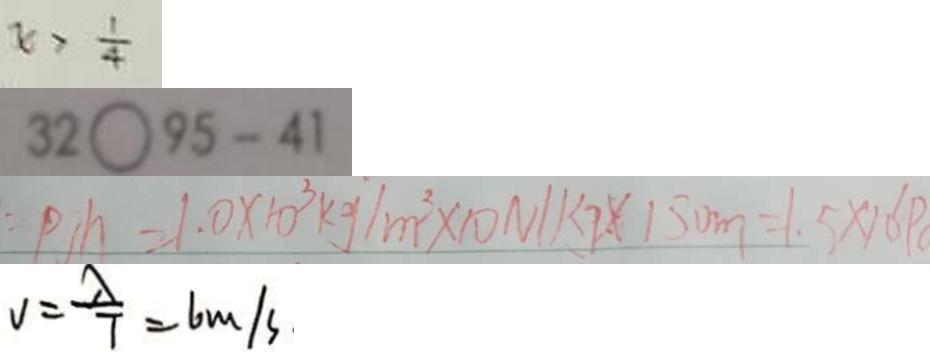<formula> <loc_0><loc_0><loc_500><loc_500>x > \frac { 1 } { 4 } 
 3 2 9 5 - 4 1 
 p h = 1 . 0 \times 1 0 ^ { 3 } k g / m ^ { 2 } \times 1 0 N / k g \times 1 5 0 m = 1 . 5 \times 1 0 p 
 v = \frac { \lambda } { 7 } = 6 m / s</formula> 